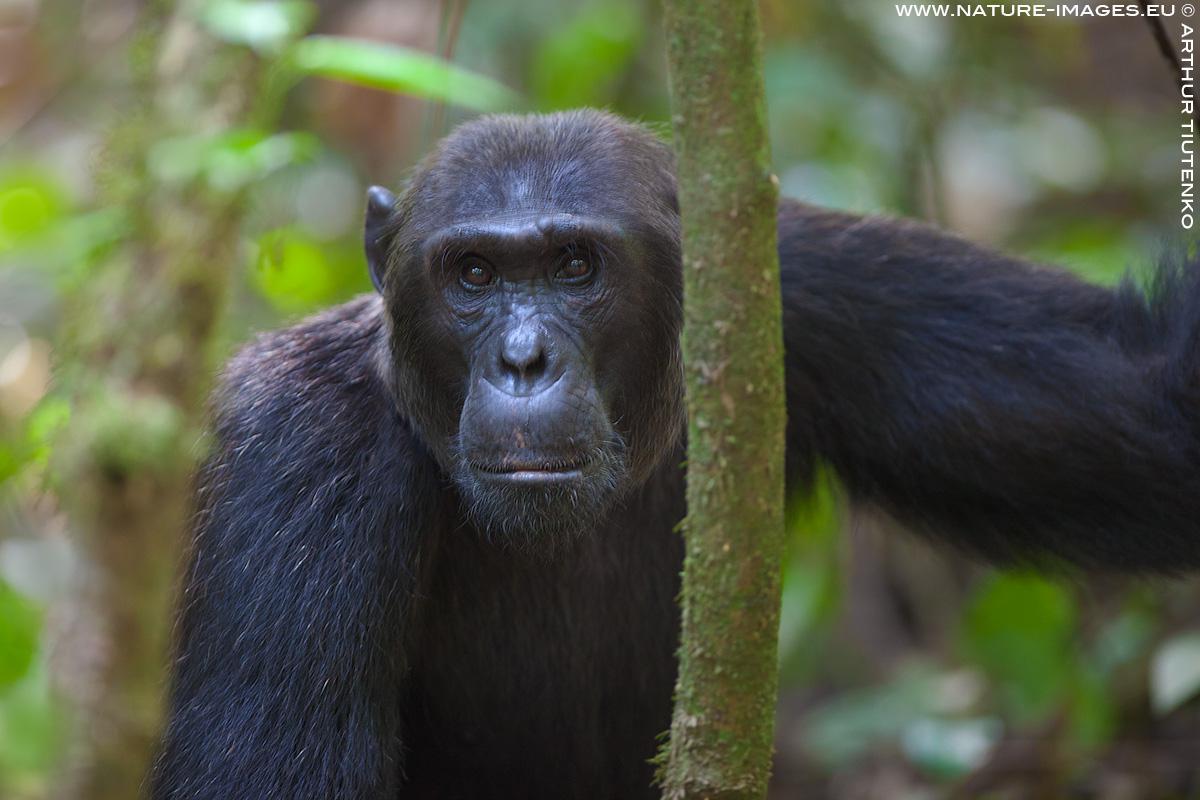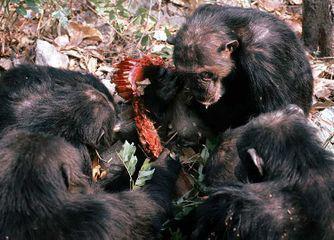The first image is the image on the left, the second image is the image on the right. For the images displayed, is the sentence "The primate in the image on the right is sitting on a tree branch." factually correct? Answer yes or no. No. The first image is the image on the left, the second image is the image on the right. For the images shown, is this caption "The right image shows a chimp looking down over a curved branch from a treetop vantage point." true? Answer yes or no. No. 